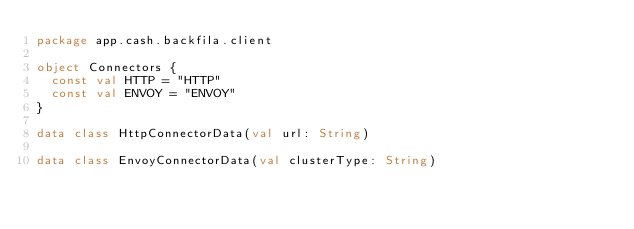Convert code to text. <code><loc_0><loc_0><loc_500><loc_500><_Kotlin_>package app.cash.backfila.client

object Connectors {
  const val HTTP = "HTTP"
  const val ENVOY = "ENVOY"
}

data class HttpConnectorData(val url: String)

data class EnvoyConnectorData(val clusterType: String)
</code> 